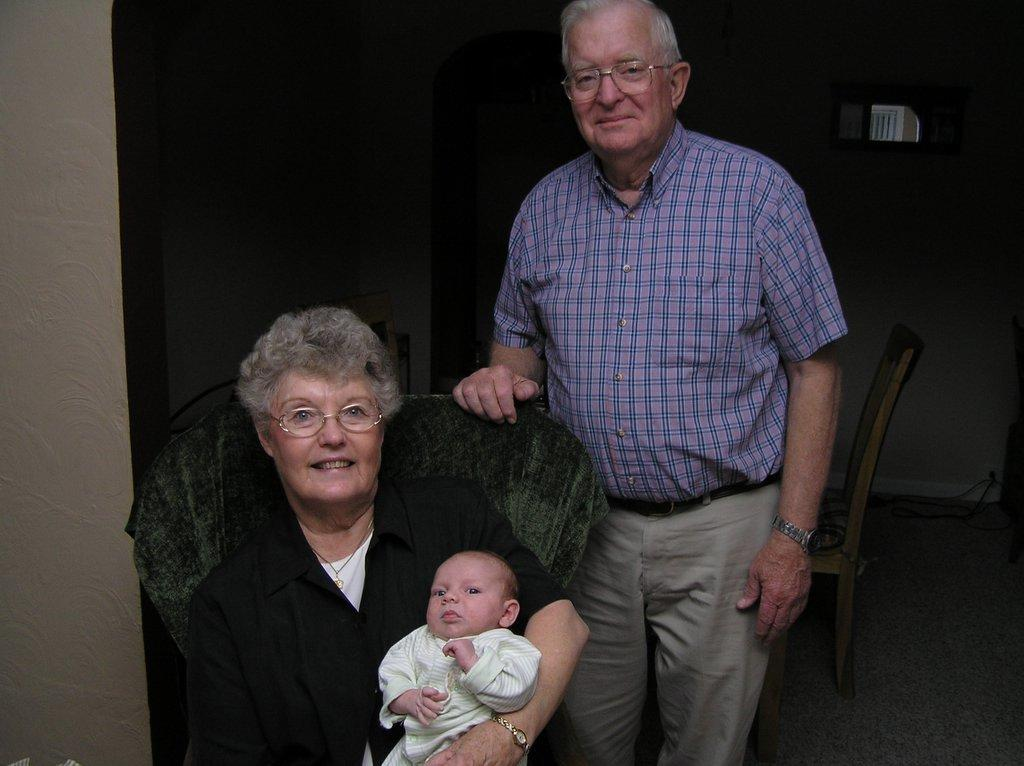What is the main subject of the image? There is a person sitting on a chair in the image. What is the person on the chair doing? The person is holding a baby. What can be seen in the background of the image? There is a wall visible in the background of the image. Are there any other people in the image? Yes, there is another person standing in the background of the image. What type of juice is being sold at the store in the image? There is no store or juice present in the image; it features a person sitting on a chair holding a baby with a wall in the background and another person standing nearby. 